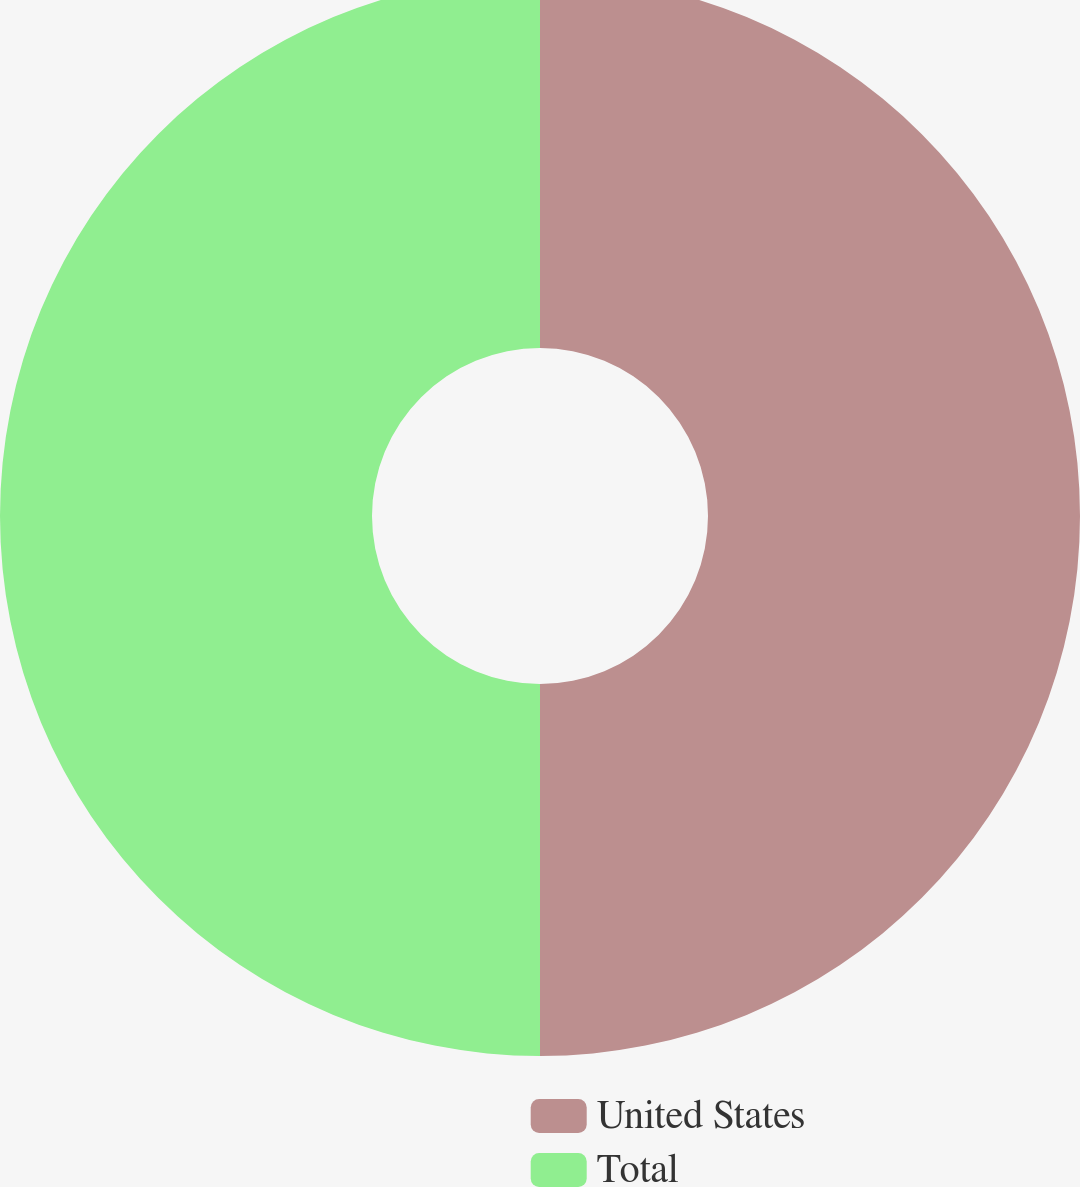Convert chart. <chart><loc_0><loc_0><loc_500><loc_500><pie_chart><fcel>United States<fcel>Total<nl><fcel>50.0%<fcel>50.0%<nl></chart> 